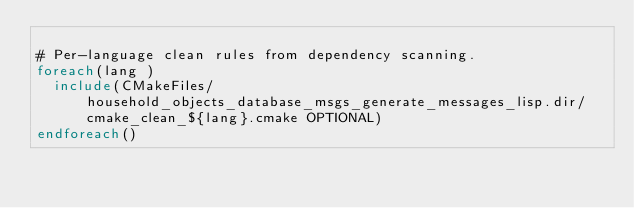Convert code to text. <code><loc_0><loc_0><loc_500><loc_500><_CMake_>
# Per-language clean rules from dependency scanning.
foreach(lang )
  include(CMakeFiles/household_objects_database_msgs_generate_messages_lisp.dir/cmake_clean_${lang}.cmake OPTIONAL)
endforeach()
</code> 